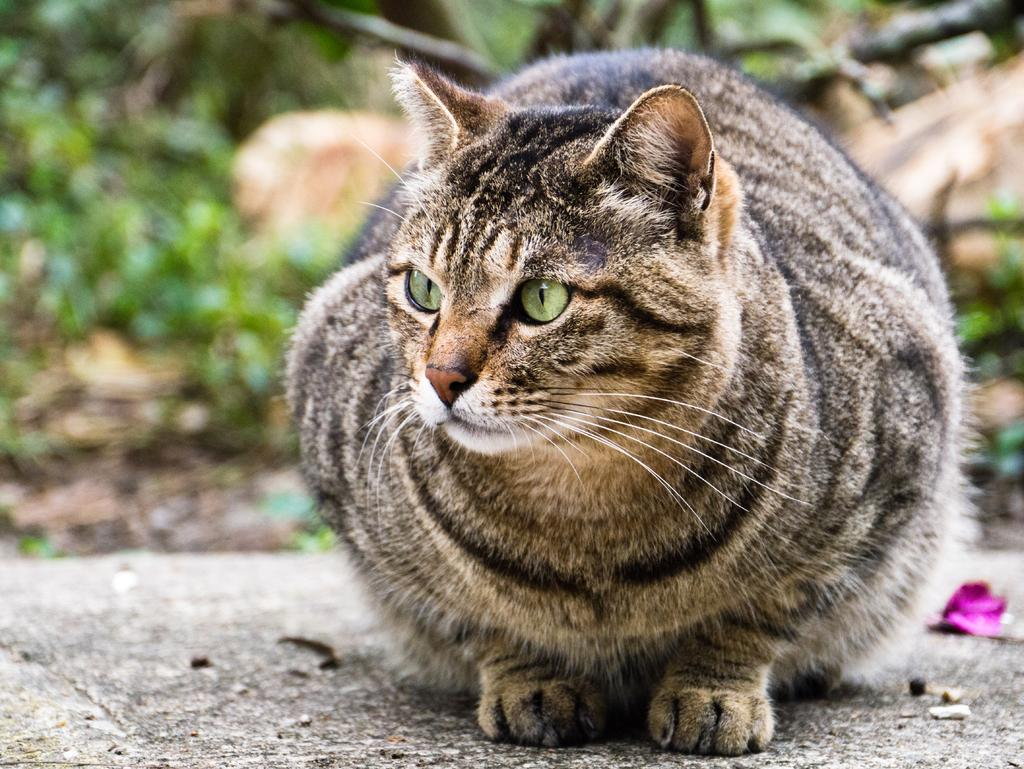What animal is present in the image? There is a cat in the image. Where is the cat located? The cat is on a rock surface. What can be seen in the background of the image? There are plants and tree branches in the background of the image. What type of skirt is the cat wearing in the image? There is no skirt present in the image, as cats do not wear clothing. 